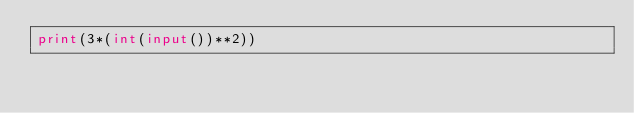<code> <loc_0><loc_0><loc_500><loc_500><_Python_>print(3*(int(input())**2))
</code> 